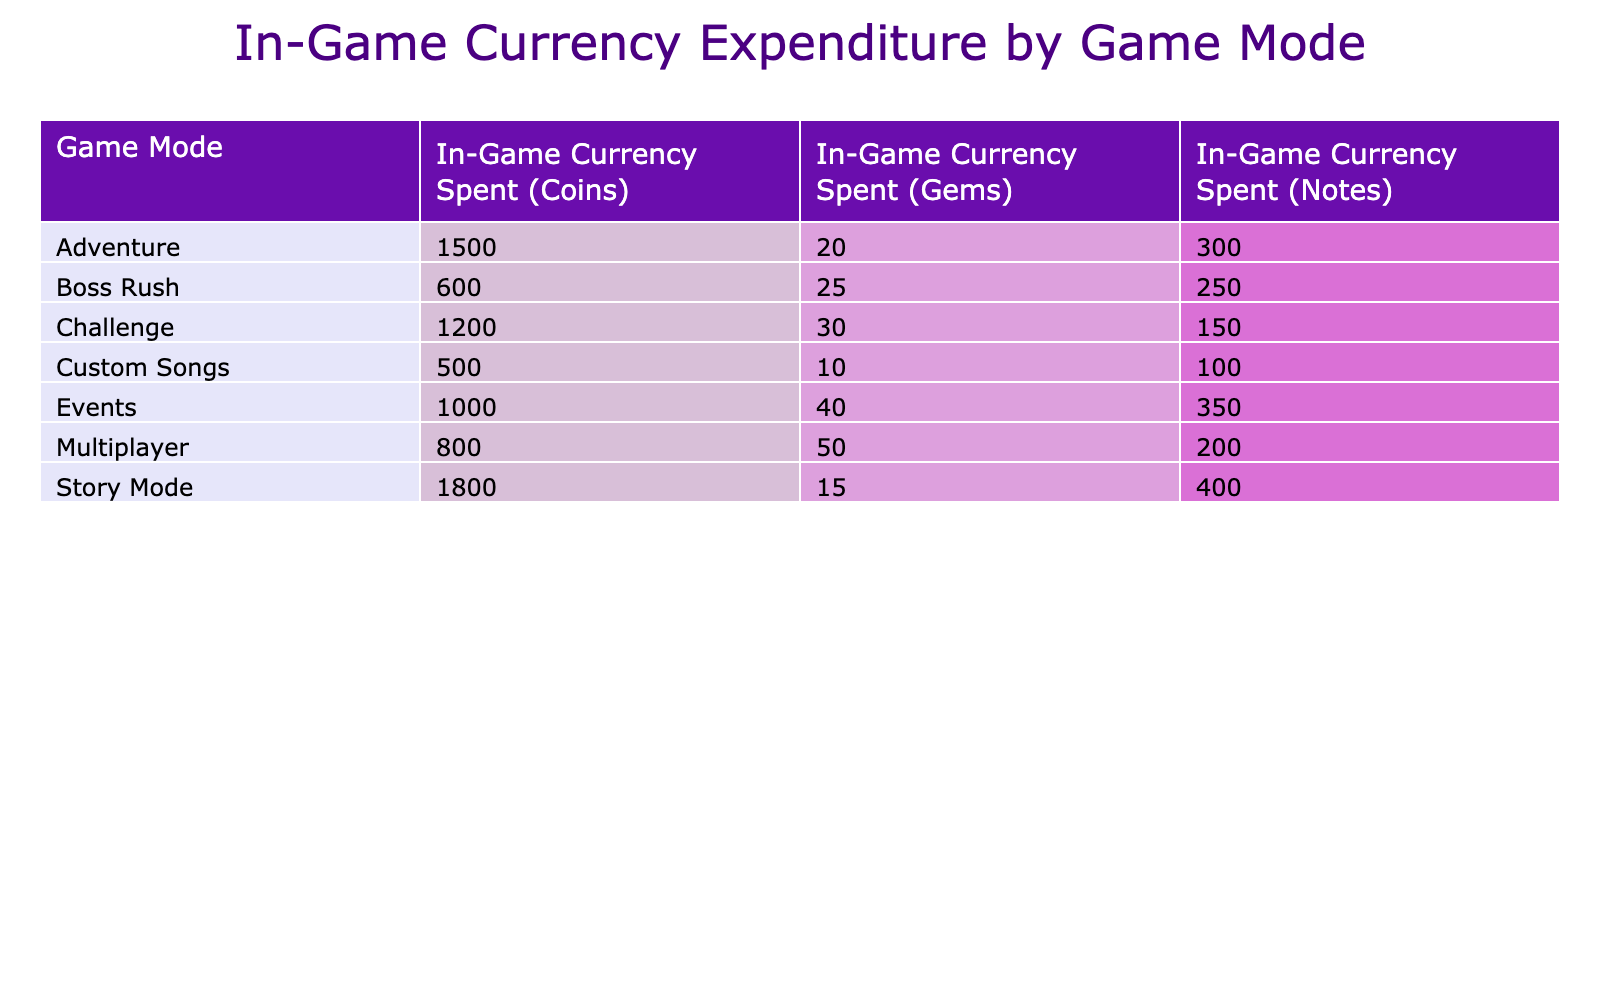What is the total amount of Coins spent in Adventure mode? The table reveals that in Adventure mode, 1500 Coins were spent. Therefore, this value is retrieved directly from the data with no additional calculations required.
Answer: 1500 Which game mode had the highest expenditure of Gems? Looking at the Gems column, Story Mode shows the highest expenditure of 15 Gems. This was identified by comparing all values under the Gems column to find the maximum.
Answer: Story Mode How much more Currency was spent in Story Mode than in Challenge mode in total? The total spent in Story Mode is 1800 Coins + 15 Gems + 400 Notes = 2215. For Challenge mode, this total is 1200 Coins + 30 Gems + 150 Notes = 1380. The difference is 2215 - 1380 = 835.
Answer: 835 Is the expenditure of Notes in Boss Rush higher than in Multiplayer mode? In Boss Rush mode, 250 Notes were spent, while in Multiplayer mode, 200 Notes were spent. Since 250 is greater than 200, the statement is true.
Answer: Yes What is the average expenditure of Coins across all game modes? All expenditures in the Coins column are: 1500 (Adventure) + 1200 (Challenge) + 800 (Multiplayer) + 1000 (Events) + 500 (Custom Songs) + 600 (Boss Rush) + 1800 (Story Mode) = 4900. There are 7 game modes, thus the average is 4900 / 7 = 700.
Answer: 700 Which is the least amount of in-game currency spent in Custom Songs mode? Observing the table, Custom Songs shows a total expenditure of 500 Coins, 10 Gems, and 100 Notes, leading to an overall low value. The least among the values is 10 Gems.
Answer: 10 Which mode requires the highest total expenditure in Gems when considering all modes? The total Gems across all modes are: 20 (Adventure) + 30 (Challenge) + 50 (Multiplayer) + 40 (Events) + 10 (Custom Songs) + 25 (Boss Rush) + 15 (Story Mode) = 190. The mode with the highest is Multiplayer with 50 Gems.
Answer: Multiplayer Calculate the total expenditure of all game modes combined. To find the total expenditure across all modes, sum all values in all categories (Coins, Gems, and Notes). The totals are: Coins = 4900, Gems = 205, Notes = 1500. Therefore, 4900 + 205 + 1500 = 6605.
Answer: 6605 